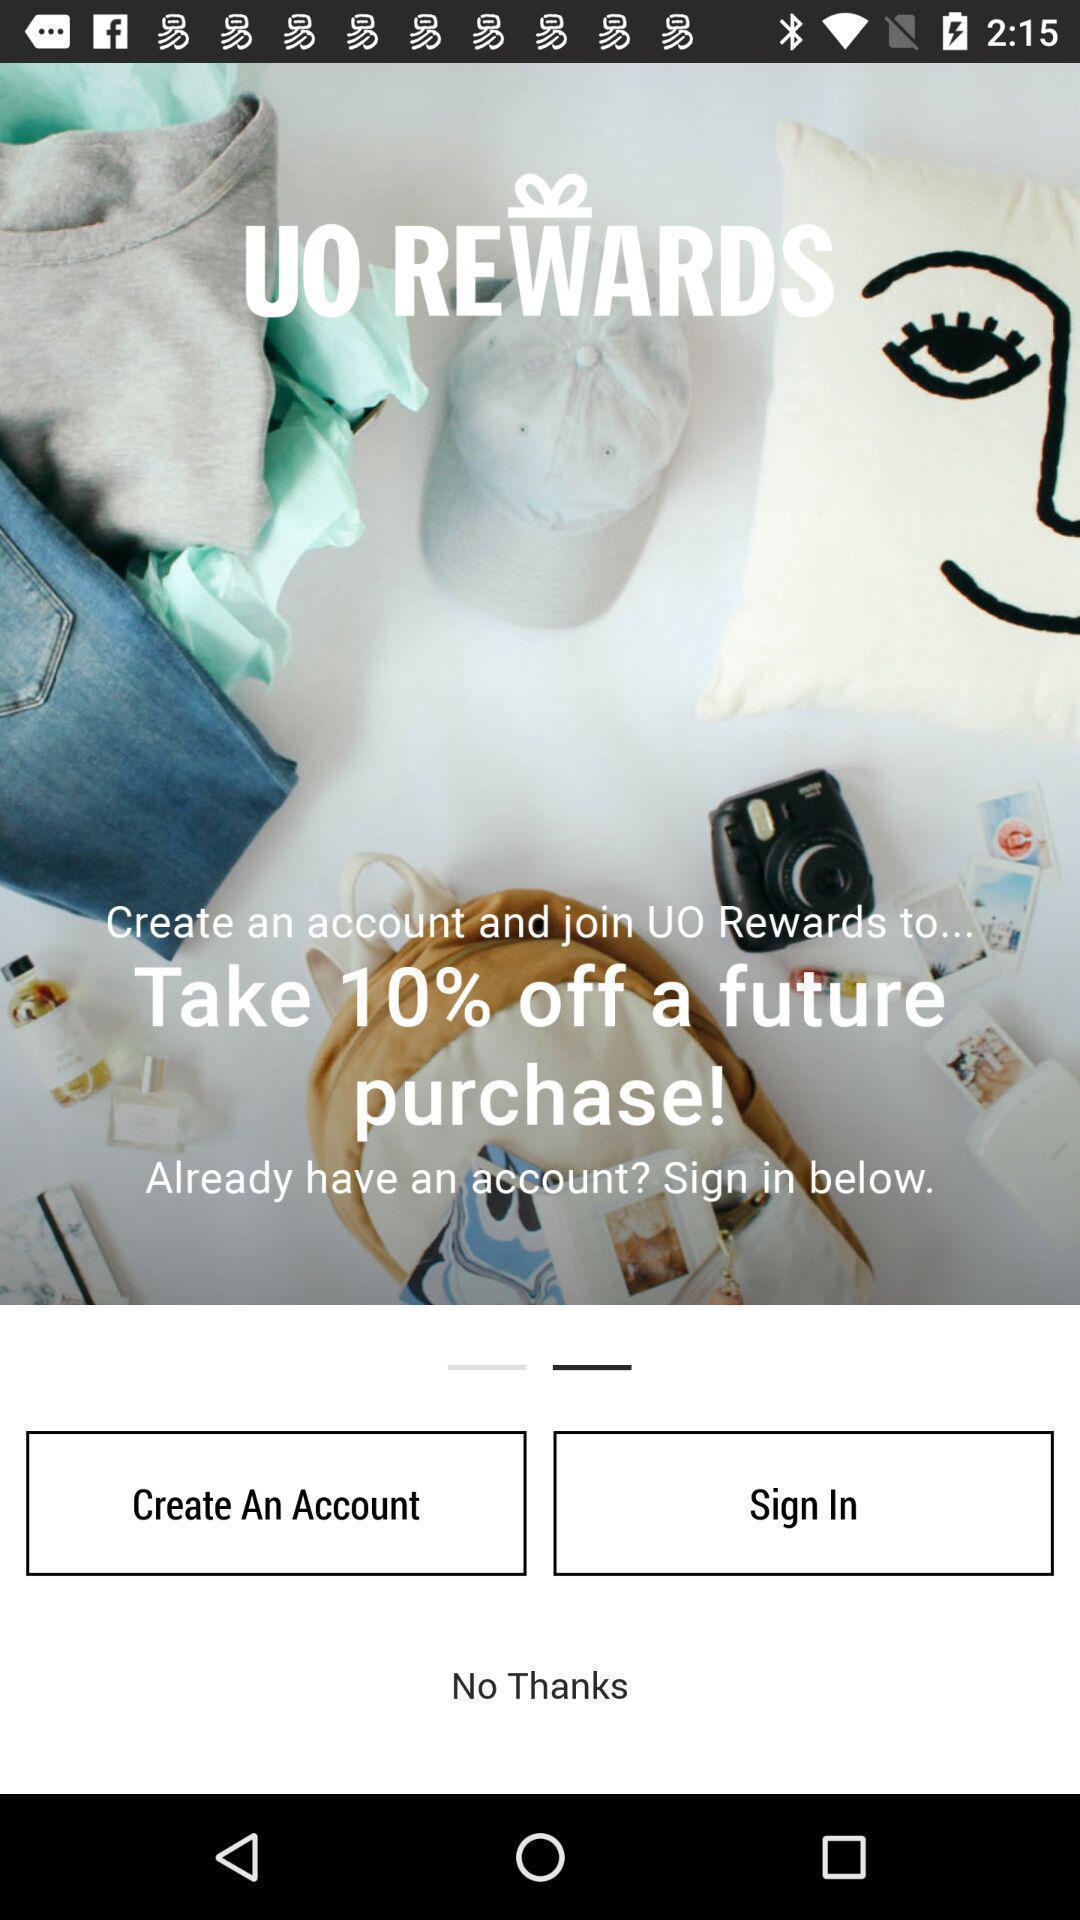Describe this image in words. Welcome page of a shopping app. 